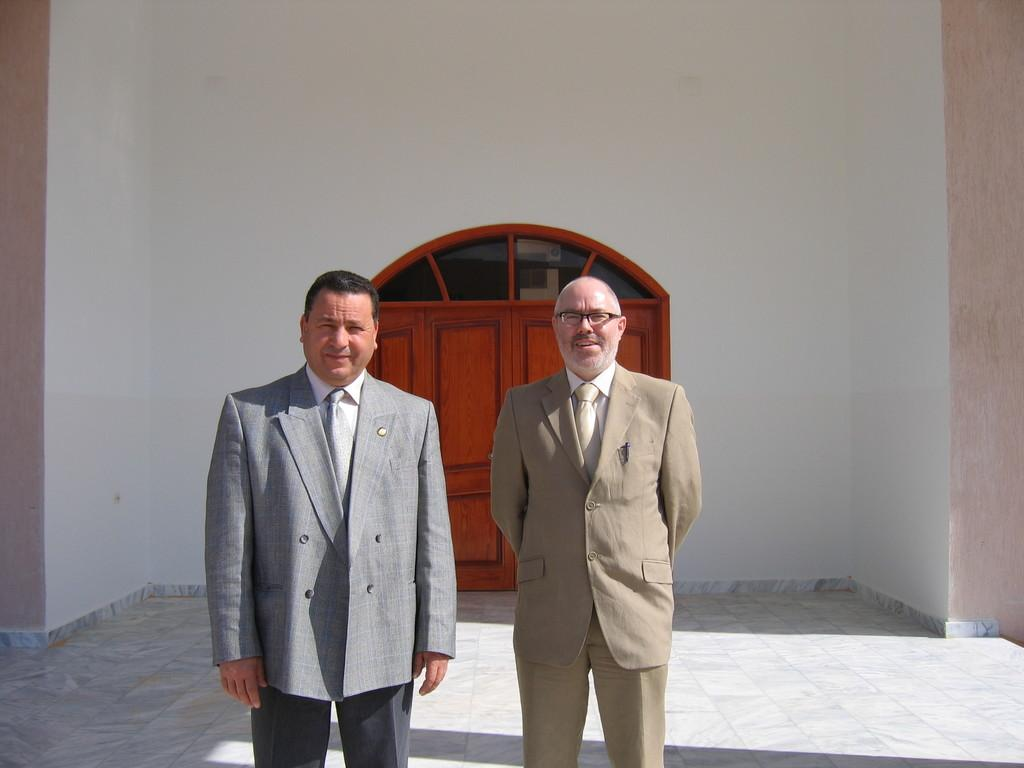How many people are in the foreground of the image? There are two persons standing in the foreground of the image. What surface are the persons standing on? The persons are standing on the floor. What can be seen in the background of the image? There is a wall and a door in the background of the background of the image. Can you describe the lighting conditions in the image? The image was likely taken during the day, as there is sufficient light. What type of dirt can be seen on the edge of the bun in the image? There is no bun or dirt present in the image; it features two persons standing on the floor with a wall and a door in the background. 